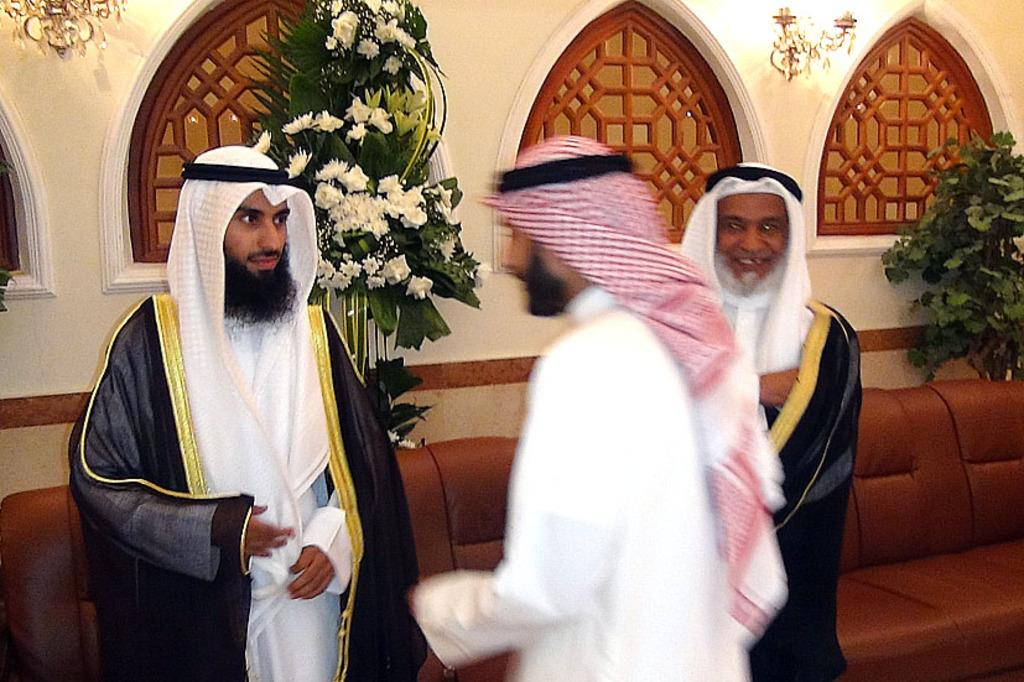How many people are in the image? There are persons standing in the image, but the exact number cannot be determined from the provided facts. What can be seen in the background of the image? In the background of the image, there is a sofa, lights on the wall, a plant with flowers, and windows. Can you describe the plant on the right side of the image? There is a plant on the right side of the image, but no specific details about its appearance are provided. What type of wax is being used to write letters on the plant in the image? There is no wax or letters present on the plant in the image. 